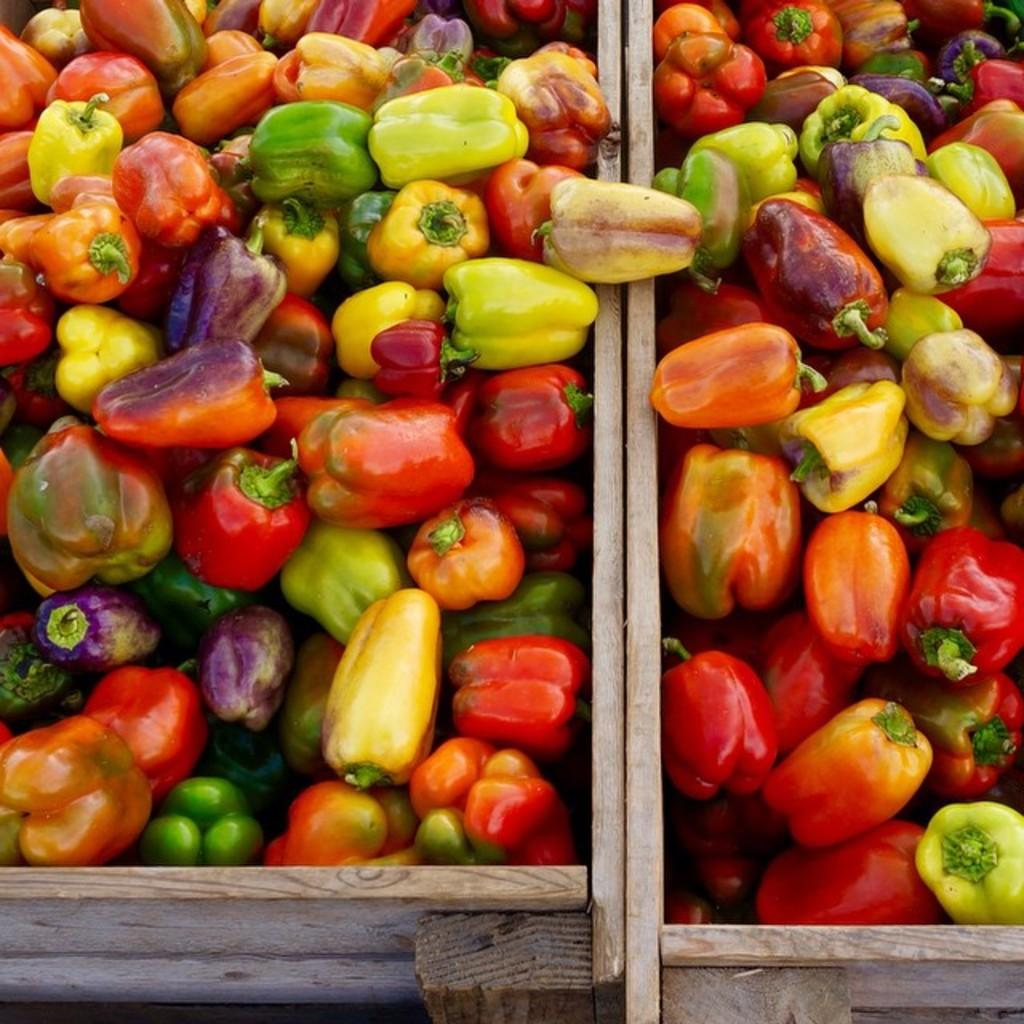What type of vegetables are present in the image? There are capsicums in the image. What color are the capsicums? The capsicums are green in color. How are the capsicums stored in the image? The capsicums are kept in wooden boxes. Can you tell me what the grandfather is requesting in the image? There is no grandfather or request present in the image; it only features capsicums in wooden boxes. 